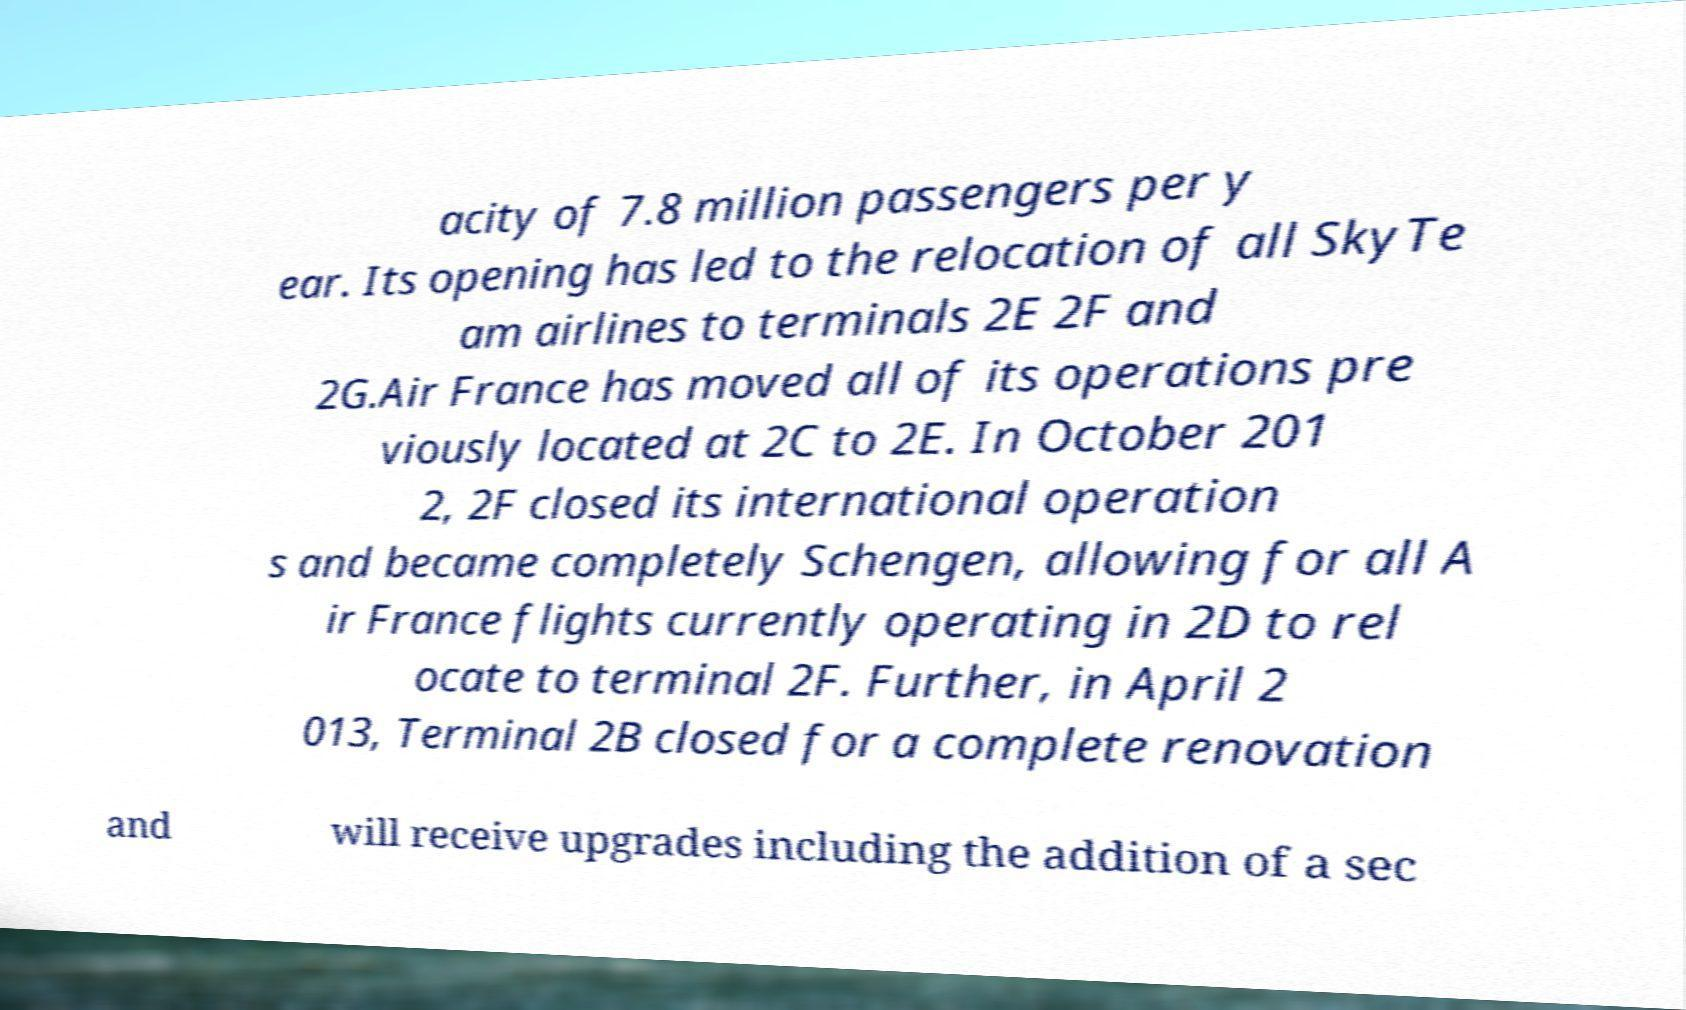For documentation purposes, I need the text within this image transcribed. Could you provide that? acity of 7.8 million passengers per y ear. Its opening has led to the relocation of all SkyTe am airlines to terminals 2E 2F and 2G.Air France has moved all of its operations pre viously located at 2C to 2E. In October 201 2, 2F closed its international operation s and became completely Schengen, allowing for all A ir France flights currently operating in 2D to rel ocate to terminal 2F. Further, in April 2 013, Terminal 2B closed for a complete renovation and will receive upgrades including the addition of a sec 